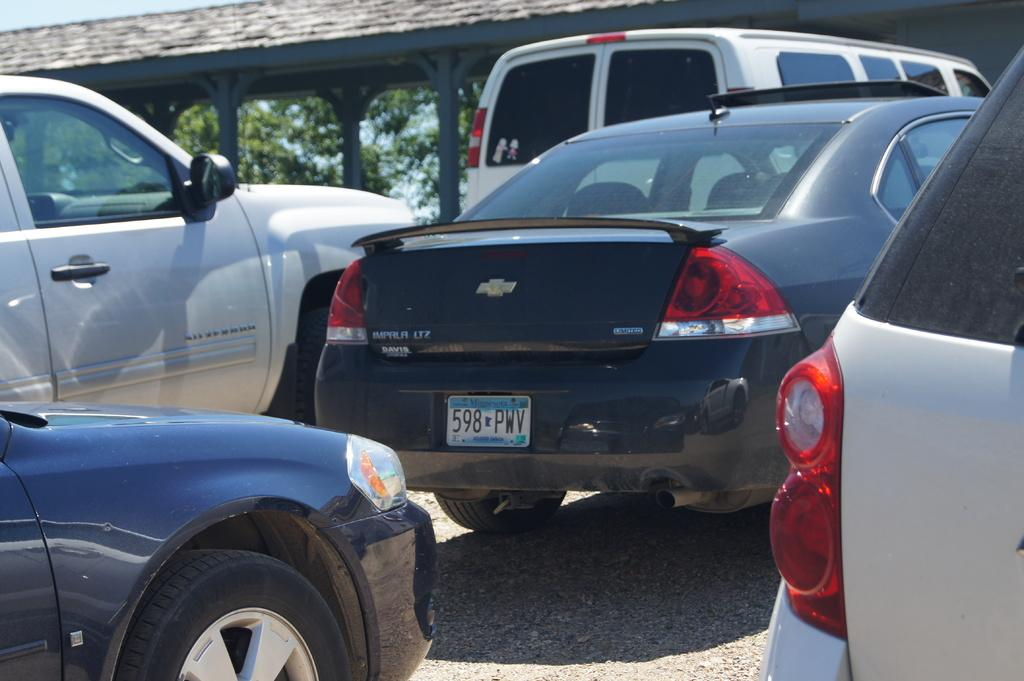What is the main subject in the middle of the image? There is a black car in the middle of the image. What can be seen around the black car? There are cars surrounding the black car. What is visible in the background of the image? There is a building in the background of the image. What type of vegetation is behind the building? There are trees behind the building. How many brothers are standing next to the black car in the image? There is no mention of brothers in the image, so we cannot determine their presence or number. 